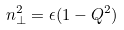<formula> <loc_0><loc_0><loc_500><loc_500>n _ { \perp } ^ { 2 } = \epsilon ( 1 - Q ^ { 2 } )</formula> 